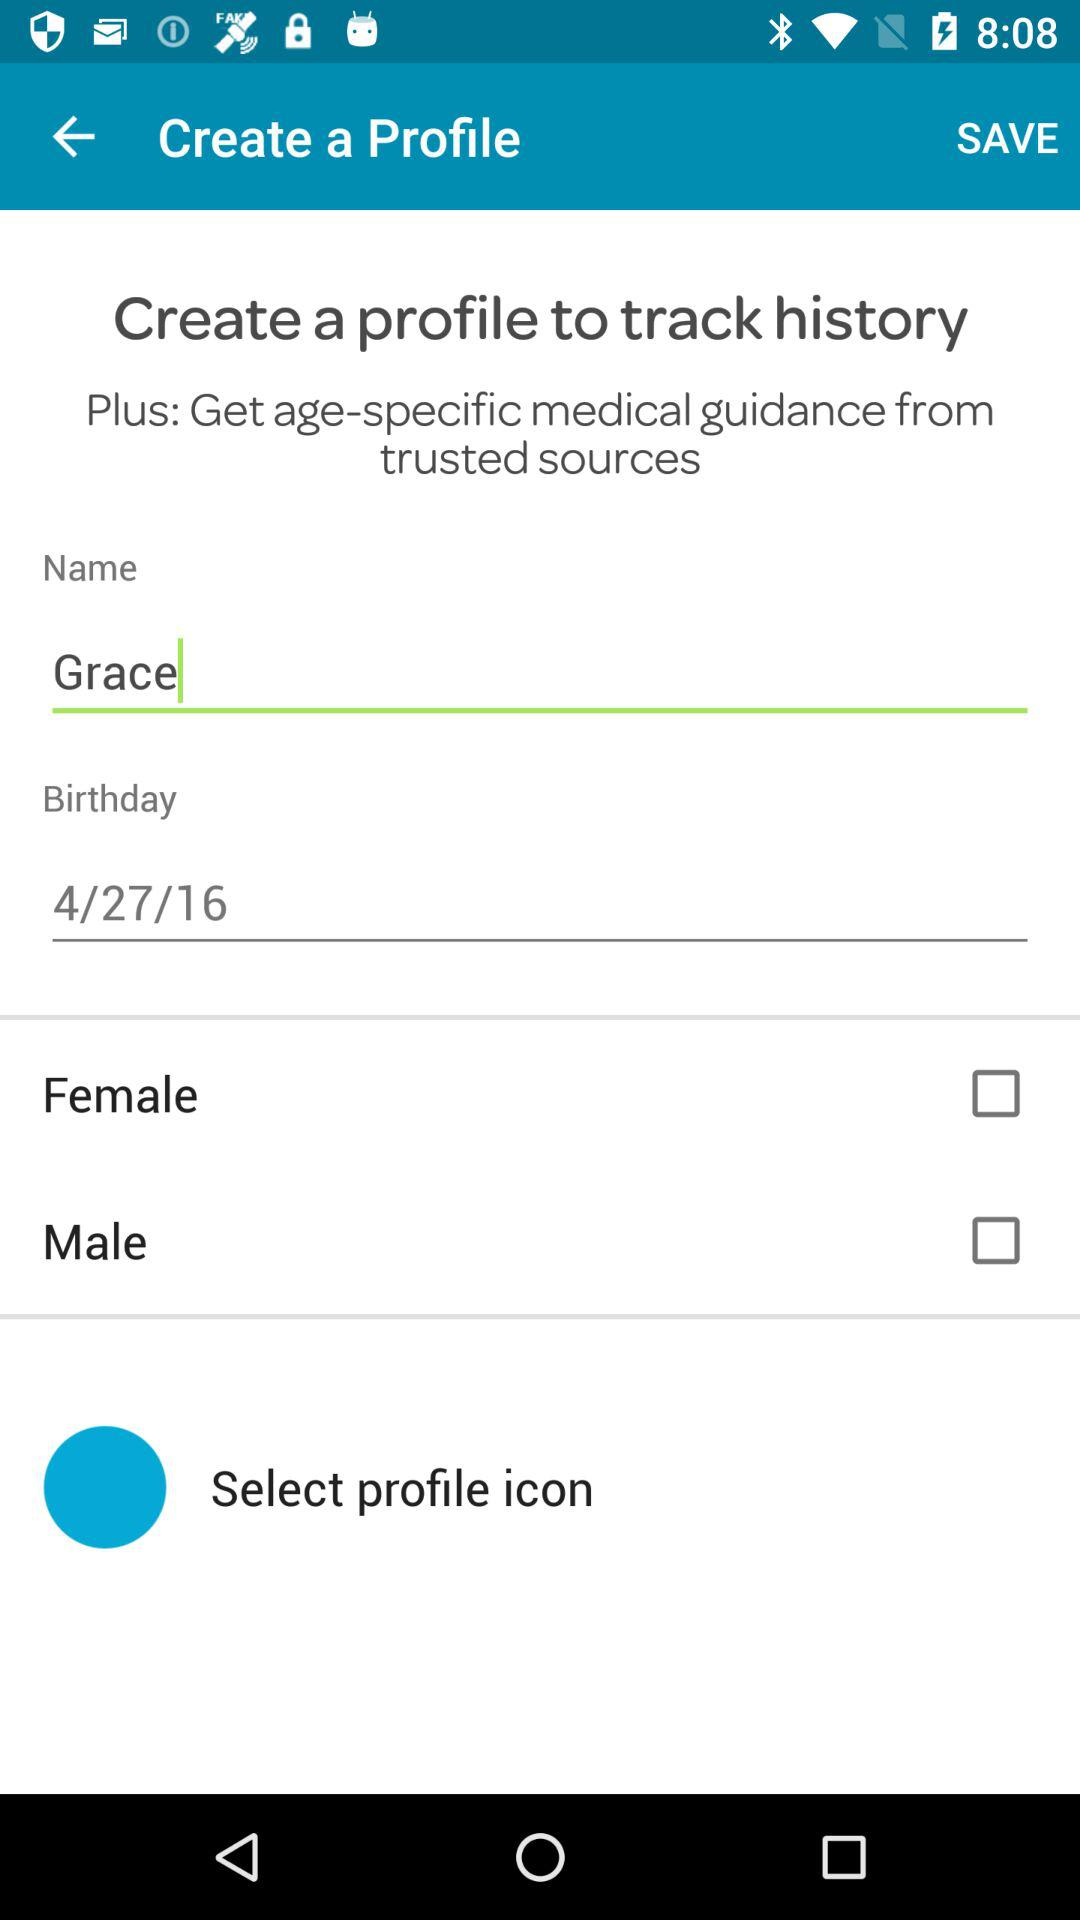What's the Plus benefit for creating profile? The Plus benefit is "Get age-specific medical guidance from trusted sources". 